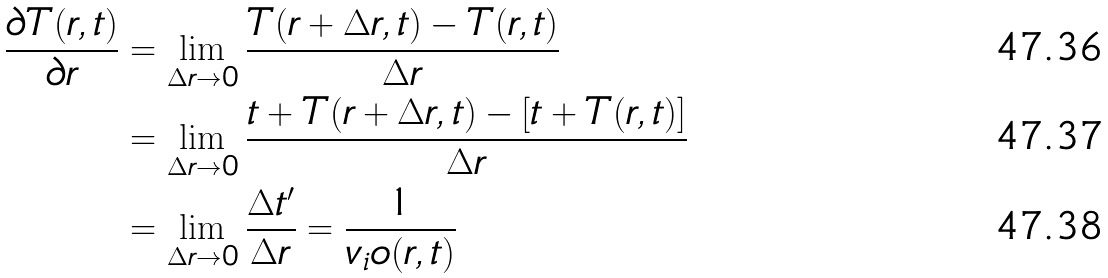<formula> <loc_0><loc_0><loc_500><loc_500>\frac { \partial T ( r , t ) } { \partial r } & = \lim _ { \Delta r \to 0 } \frac { T ( r + \Delta r , t ) - T ( r , t ) } { \Delta r } \\ & = \lim _ { \Delta r \to 0 } \frac { t + T ( r + \Delta r , t ) - [ t + T ( r , t ) ] } { \Delta r } \\ & = \lim _ { \Delta r \to 0 } \frac { \Delta t ^ { \prime } } { \Delta r } = \frac { 1 } { v _ { i } o ( r , t ) }</formula> 